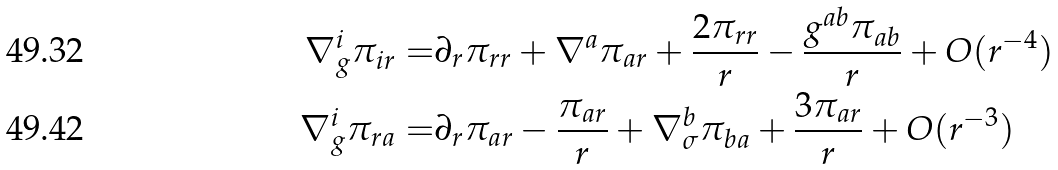<formula> <loc_0><loc_0><loc_500><loc_500>\nabla ^ { i } _ { g } \pi _ { i r } = & \partial _ { r } \pi _ { r r } + \nabla ^ { a } \pi _ { a r } + \frac { 2 \pi _ { r r } } { r } - \frac { g ^ { a b } \pi _ { a b } } { r } + O ( r ^ { - 4 } ) \\ \nabla ^ { i } _ { g } \pi _ { r a } = & \partial _ { r } \pi _ { a r } - \frac { \pi _ { a r } } { r } + \nabla ^ { b } _ { \sigma } \pi _ { b a } + \frac { 3 \pi _ { a r } } { r } + O ( r ^ { - 3 } )</formula> 